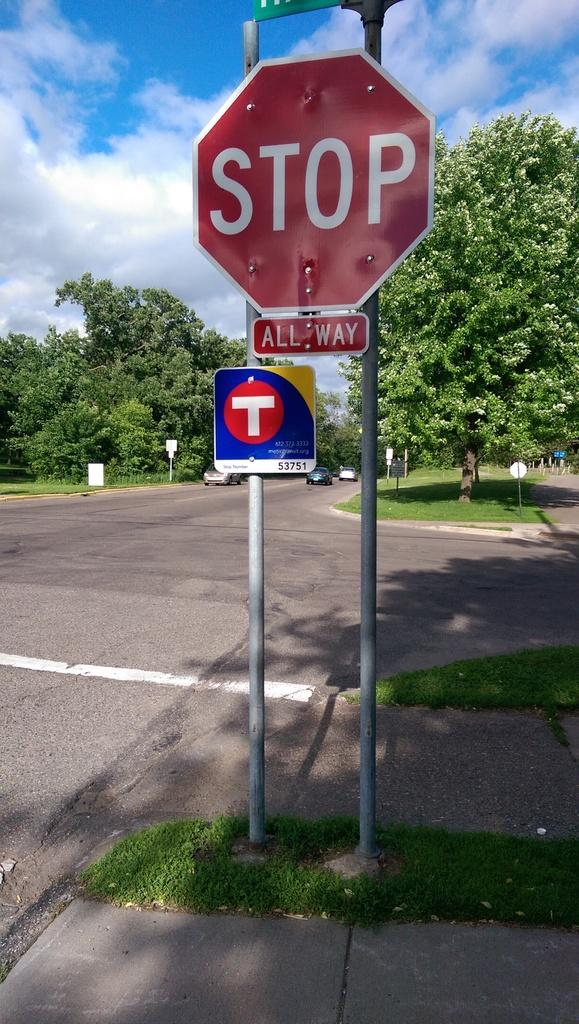Provide a one-sentence caption for the provided image. An all-way stop sign is attached to a pole above another sign with a "T" on it. 